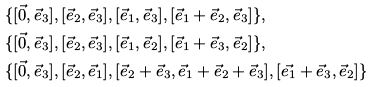<formula> <loc_0><loc_0><loc_500><loc_500>& \{ [ \vec { 0 } , \vec { e } _ { 3 } ] , [ \vec { e } _ { 2 } , \vec { e } _ { 3 } ] , [ \vec { e } _ { 1 } , \vec { e } _ { 3 } ] , [ \vec { e } _ { 1 } + \vec { e } _ { 2 } , \vec { e } _ { 3 } ] \} , \\ & \{ [ \vec { 0 } , \vec { e } _ { 3 } ] , [ \vec { e } _ { 2 } , \vec { e } _ { 3 } ] , [ \vec { e } _ { 1 } , \vec { e } _ { 2 } ] , [ \vec { e } _ { 1 } + \vec { e } _ { 3 } , \vec { e } _ { 2 } ] \} , \\ & \{ [ \vec { 0 } , \vec { e } _ { 3 } ] , [ \vec { e } _ { 2 } , \vec { e } _ { 1 } ] , [ \vec { e } _ { 2 } + \vec { e } _ { 3 } , \vec { e } _ { 1 } + \vec { e } _ { 2 } + \vec { e } _ { 3 } ] , [ \vec { e _ { 1 } } + \vec { e } _ { 3 } , \vec { e } _ { 2 } ] \}</formula> 